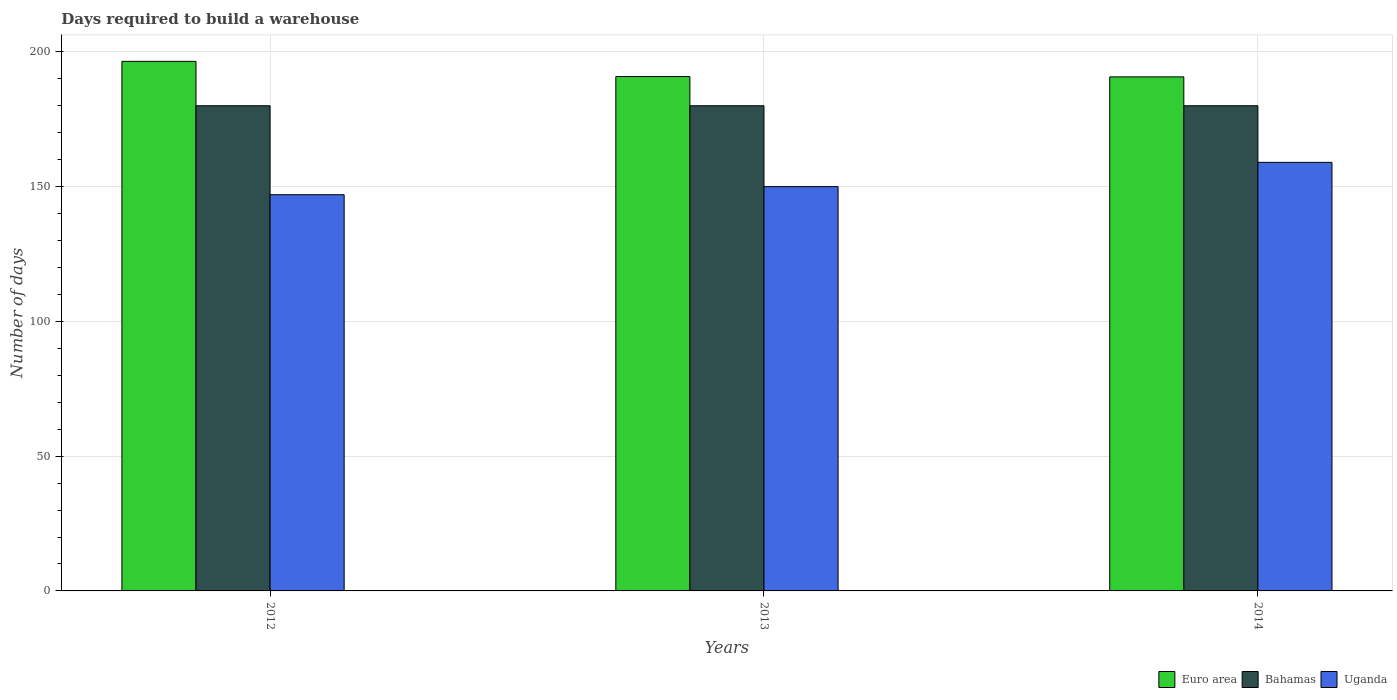Are the number of bars per tick equal to the number of legend labels?
Provide a succinct answer. Yes. How many bars are there on the 1st tick from the right?
Provide a succinct answer. 3. In how many cases, is the number of bars for a given year not equal to the number of legend labels?
Provide a short and direct response. 0. What is the days required to build a warehouse in in Bahamas in 2012?
Your answer should be compact. 180. Across all years, what is the maximum days required to build a warehouse in in Bahamas?
Your response must be concise. 180. Across all years, what is the minimum days required to build a warehouse in in Bahamas?
Offer a very short reply. 180. In which year was the days required to build a warehouse in in Euro area minimum?
Offer a terse response. 2014. What is the total days required to build a warehouse in in Uganda in the graph?
Your response must be concise. 456. What is the difference between the days required to build a warehouse in in Euro area in 2012 and that in 2014?
Provide a succinct answer. 5.76. What is the difference between the days required to build a warehouse in in Uganda in 2012 and the days required to build a warehouse in in Bahamas in 2013?
Your answer should be compact. -33. What is the average days required to build a warehouse in in Bahamas per year?
Keep it short and to the point. 180. In the year 2012, what is the difference between the days required to build a warehouse in in Bahamas and days required to build a warehouse in in Uganda?
Give a very brief answer. 33. Is the difference between the days required to build a warehouse in in Bahamas in 2013 and 2014 greater than the difference between the days required to build a warehouse in in Uganda in 2013 and 2014?
Your answer should be compact. Yes. What is the difference between the highest and the lowest days required to build a warehouse in in Uganda?
Your answer should be compact. 12. In how many years, is the days required to build a warehouse in in Uganda greater than the average days required to build a warehouse in in Uganda taken over all years?
Provide a succinct answer. 1. Is the sum of the days required to build a warehouse in in Euro area in 2012 and 2013 greater than the maximum days required to build a warehouse in in Bahamas across all years?
Offer a very short reply. Yes. What does the 2nd bar from the left in 2012 represents?
Provide a short and direct response. Bahamas. What does the 1st bar from the right in 2013 represents?
Your answer should be very brief. Uganda. Is it the case that in every year, the sum of the days required to build a warehouse in in Uganda and days required to build a warehouse in in Euro area is greater than the days required to build a warehouse in in Bahamas?
Make the answer very short. Yes. How many bars are there?
Your answer should be compact. 9. Does the graph contain any zero values?
Ensure brevity in your answer.  No. What is the title of the graph?
Provide a short and direct response. Days required to build a warehouse. Does "Micronesia" appear as one of the legend labels in the graph?
Your response must be concise. No. What is the label or title of the Y-axis?
Offer a terse response. Number of days. What is the Number of days in Euro area in 2012?
Make the answer very short. 196.47. What is the Number of days in Bahamas in 2012?
Your answer should be compact. 180. What is the Number of days in Uganda in 2012?
Your answer should be compact. 147. What is the Number of days of Euro area in 2013?
Ensure brevity in your answer.  190.84. What is the Number of days in Bahamas in 2013?
Offer a terse response. 180. What is the Number of days of Uganda in 2013?
Offer a terse response. 150. What is the Number of days in Euro area in 2014?
Offer a very short reply. 190.71. What is the Number of days of Bahamas in 2014?
Ensure brevity in your answer.  180. What is the Number of days of Uganda in 2014?
Give a very brief answer. 159. Across all years, what is the maximum Number of days in Euro area?
Make the answer very short. 196.47. Across all years, what is the maximum Number of days in Bahamas?
Give a very brief answer. 180. Across all years, what is the maximum Number of days in Uganda?
Provide a succinct answer. 159. Across all years, what is the minimum Number of days in Euro area?
Ensure brevity in your answer.  190.71. Across all years, what is the minimum Number of days of Bahamas?
Make the answer very short. 180. Across all years, what is the minimum Number of days in Uganda?
Ensure brevity in your answer.  147. What is the total Number of days of Euro area in the graph?
Provide a succinct answer. 578.03. What is the total Number of days of Bahamas in the graph?
Your answer should be very brief. 540. What is the total Number of days of Uganda in the graph?
Your response must be concise. 456. What is the difference between the Number of days in Euro area in 2012 and that in 2013?
Your response must be concise. 5.63. What is the difference between the Number of days in Uganda in 2012 and that in 2013?
Offer a very short reply. -3. What is the difference between the Number of days in Euro area in 2012 and that in 2014?
Ensure brevity in your answer.  5.76. What is the difference between the Number of days of Bahamas in 2012 and that in 2014?
Ensure brevity in your answer.  0. What is the difference between the Number of days in Euro area in 2013 and that in 2014?
Your answer should be very brief. 0.13. What is the difference between the Number of days of Bahamas in 2013 and that in 2014?
Give a very brief answer. 0. What is the difference between the Number of days of Uganda in 2013 and that in 2014?
Provide a succinct answer. -9. What is the difference between the Number of days of Euro area in 2012 and the Number of days of Bahamas in 2013?
Make the answer very short. 16.47. What is the difference between the Number of days in Euro area in 2012 and the Number of days in Uganda in 2013?
Ensure brevity in your answer.  46.47. What is the difference between the Number of days of Bahamas in 2012 and the Number of days of Uganda in 2013?
Give a very brief answer. 30. What is the difference between the Number of days of Euro area in 2012 and the Number of days of Bahamas in 2014?
Provide a succinct answer. 16.47. What is the difference between the Number of days of Euro area in 2012 and the Number of days of Uganda in 2014?
Make the answer very short. 37.47. What is the difference between the Number of days in Euro area in 2013 and the Number of days in Bahamas in 2014?
Your answer should be very brief. 10.84. What is the difference between the Number of days of Euro area in 2013 and the Number of days of Uganda in 2014?
Make the answer very short. 31.84. What is the difference between the Number of days of Bahamas in 2013 and the Number of days of Uganda in 2014?
Provide a succinct answer. 21. What is the average Number of days of Euro area per year?
Offer a terse response. 192.68. What is the average Number of days of Bahamas per year?
Provide a short and direct response. 180. What is the average Number of days of Uganda per year?
Keep it short and to the point. 152. In the year 2012, what is the difference between the Number of days of Euro area and Number of days of Bahamas?
Provide a short and direct response. 16.47. In the year 2012, what is the difference between the Number of days in Euro area and Number of days in Uganda?
Your answer should be very brief. 49.47. In the year 2013, what is the difference between the Number of days of Euro area and Number of days of Bahamas?
Offer a terse response. 10.84. In the year 2013, what is the difference between the Number of days in Euro area and Number of days in Uganda?
Your answer should be compact. 40.84. In the year 2014, what is the difference between the Number of days of Euro area and Number of days of Bahamas?
Make the answer very short. 10.71. In the year 2014, what is the difference between the Number of days in Euro area and Number of days in Uganda?
Your answer should be compact. 31.71. What is the ratio of the Number of days of Euro area in 2012 to that in 2013?
Offer a terse response. 1.03. What is the ratio of the Number of days of Uganda in 2012 to that in 2013?
Provide a short and direct response. 0.98. What is the ratio of the Number of days in Euro area in 2012 to that in 2014?
Keep it short and to the point. 1.03. What is the ratio of the Number of days of Bahamas in 2012 to that in 2014?
Your answer should be very brief. 1. What is the ratio of the Number of days in Uganda in 2012 to that in 2014?
Offer a terse response. 0.92. What is the ratio of the Number of days of Bahamas in 2013 to that in 2014?
Give a very brief answer. 1. What is the ratio of the Number of days in Uganda in 2013 to that in 2014?
Offer a terse response. 0.94. What is the difference between the highest and the second highest Number of days of Euro area?
Your answer should be very brief. 5.63. What is the difference between the highest and the second highest Number of days of Uganda?
Ensure brevity in your answer.  9. What is the difference between the highest and the lowest Number of days of Euro area?
Your answer should be compact. 5.76. What is the difference between the highest and the lowest Number of days in Uganda?
Your answer should be very brief. 12. 